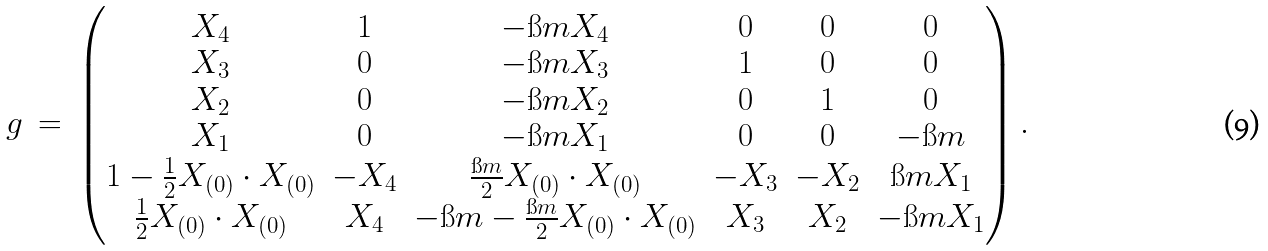Convert formula to latex. <formula><loc_0><loc_0><loc_500><loc_500>g \ = \ \begin{pmatrix} X _ { 4 } & 1 & - \i m X _ { 4 } & 0 & 0 & 0 \\ X _ { 3 } & 0 & - \i m X _ { 3 } & 1 & 0 & 0 \\ X _ { 2 } & 0 & - \i m X _ { 2 } & 0 & 1 & 0 \\ X _ { 1 } & 0 & - \i m X _ { 1 } & 0 & 0 & - \i m \\ 1 - \frac { 1 } { 2 } X _ { ( 0 ) } \cdot X _ { ( 0 ) } & - X _ { 4 } & \frac { \i m } { 2 } X _ { ( 0 ) } \cdot X _ { ( 0 ) } & - X _ { 3 } & - X _ { 2 } & \i m X _ { 1 } \\ \frac { 1 } { 2 } X _ { ( 0 ) } \cdot X _ { ( 0 ) } & X _ { 4 } & - \i m - \frac { \i m } { 2 } X _ { ( 0 ) } \cdot X _ { ( 0 ) } & X _ { 3 } & X _ { 2 } & - \i m X _ { 1 } \end{pmatrix} .</formula> 